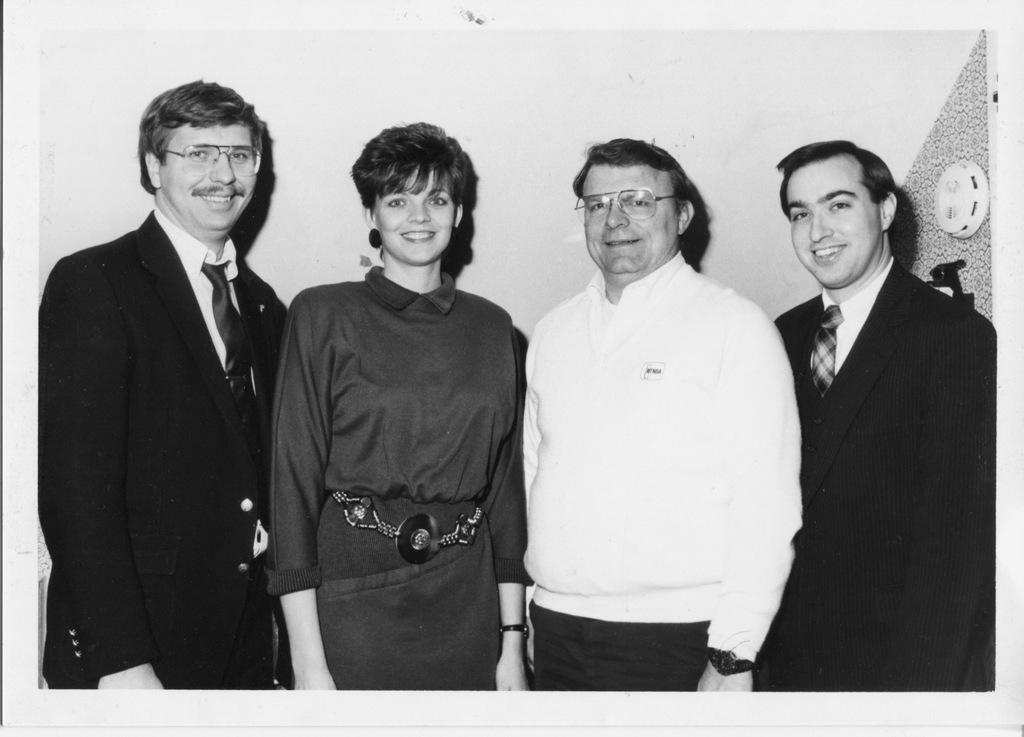How many people are present in the image? There are four people in the image: three men and one woman. Can you describe the appearance of any of the men? Two of the men are wearing spectacles. What is located behind the persons in the image? There is a wall behind the persons in the image. What can be seen on the wall? There is an object on the wall. What type of waves can be seen crashing on the shore in the image? There is no shore or waves present in the image; it features four people standing in front of a wall. What kind of humor is being displayed by the woman in the image? There is no indication of humor or any specific emotion being displayed by the woman in the image. 